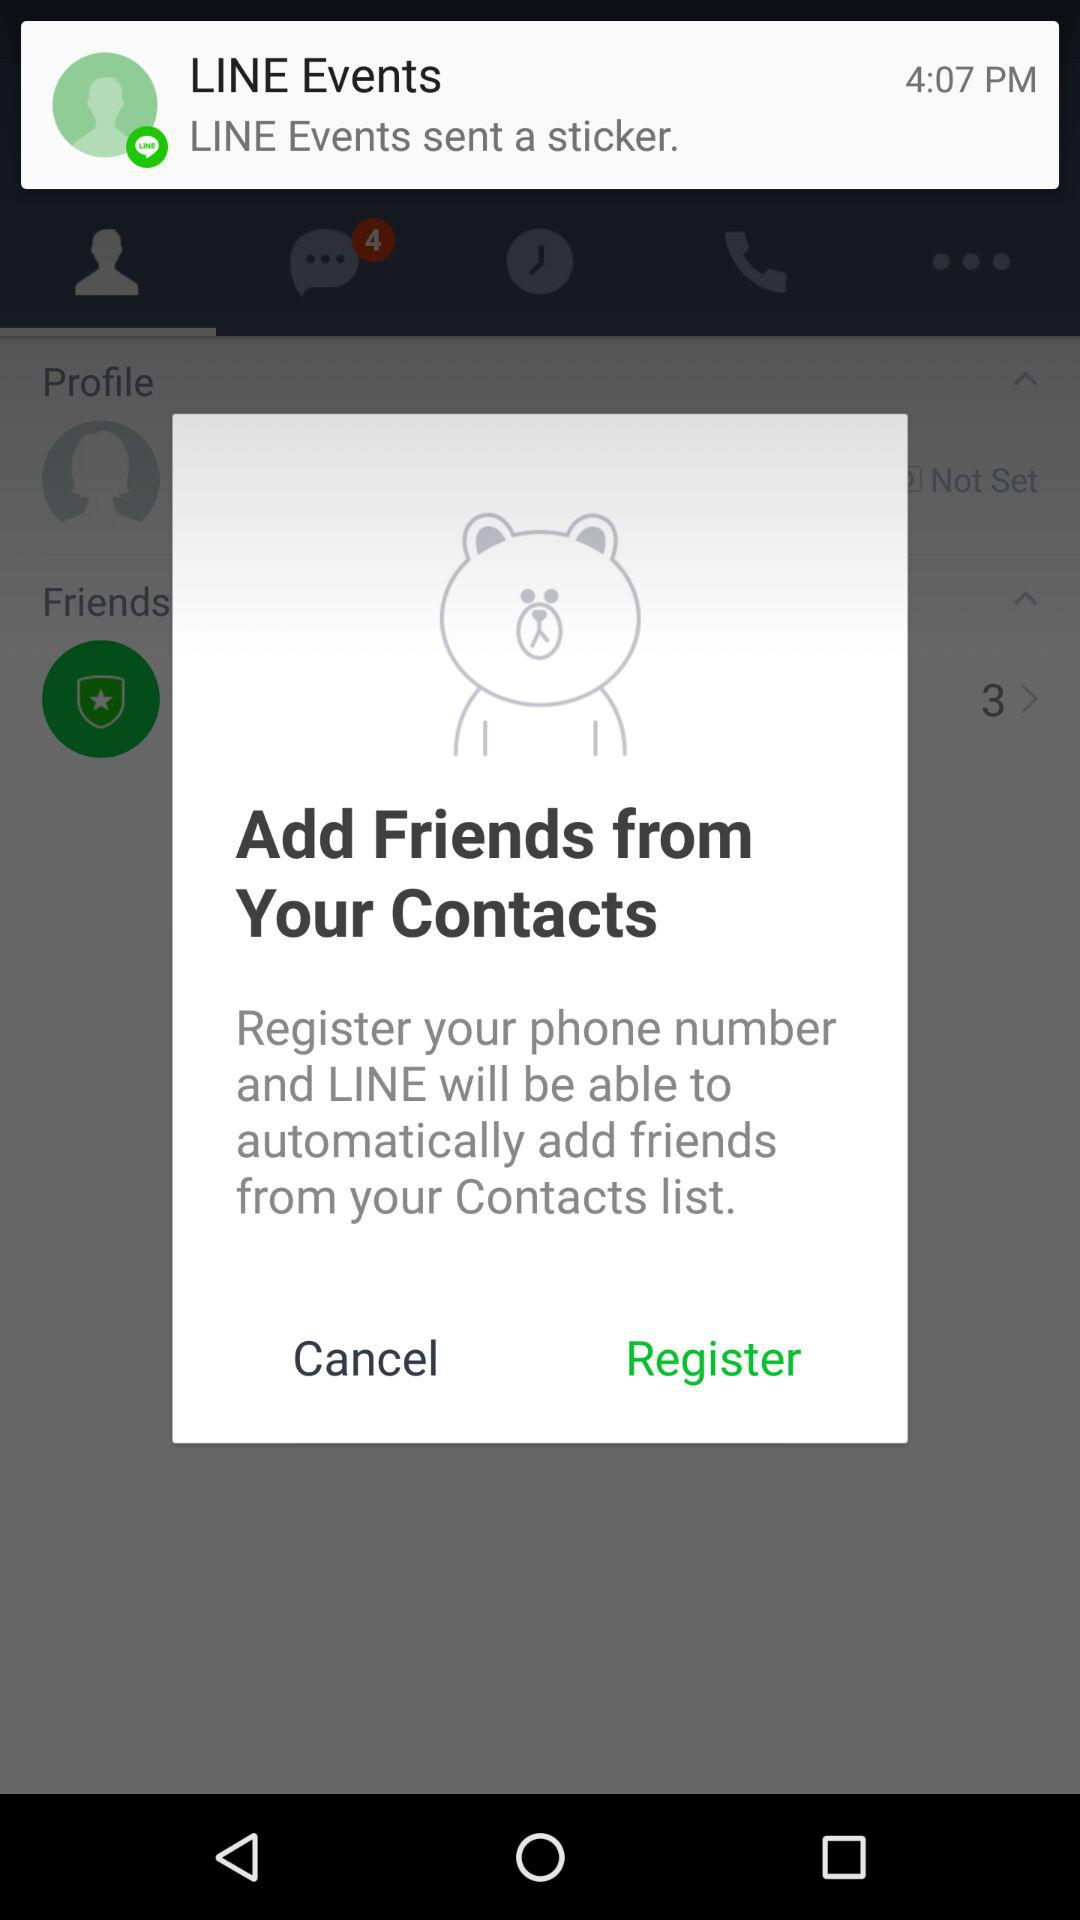At what time was the sticker sent? The sticker was sent at 4:07 PM. 